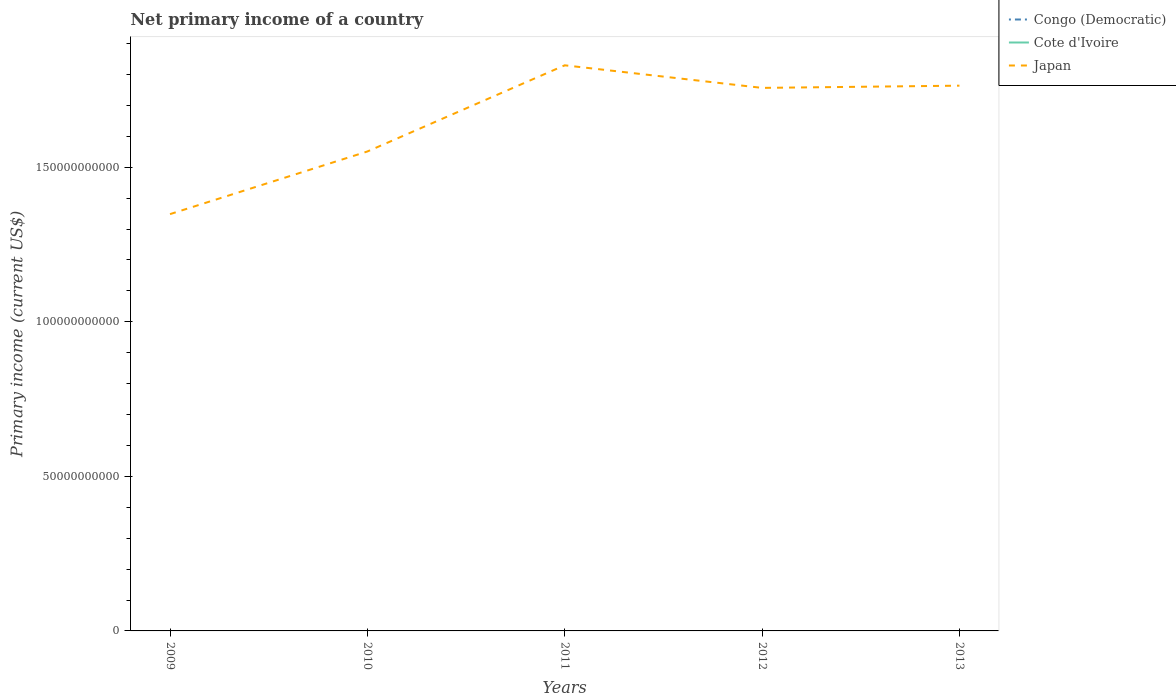Does the line corresponding to Japan intersect with the line corresponding to Congo (Democratic)?
Offer a terse response. No. Is the number of lines equal to the number of legend labels?
Ensure brevity in your answer.  No. Across all years, what is the maximum primary income in Congo (Democratic)?
Ensure brevity in your answer.  0. What is the total primary income in Japan in the graph?
Your response must be concise. 7.31e+09. Is the primary income in Cote d'Ivoire strictly greater than the primary income in Japan over the years?
Make the answer very short. Yes. How many lines are there?
Your answer should be very brief. 1. What is the difference between two consecutive major ticks on the Y-axis?
Provide a succinct answer. 5.00e+1. Are the values on the major ticks of Y-axis written in scientific E-notation?
Ensure brevity in your answer.  No. Does the graph contain any zero values?
Ensure brevity in your answer.  Yes. Does the graph contain grids?
Your answer should be very brief. No. What is the title of the graph?
Your response must be concise. Net primary income of a country. Does "Australia" appear as one of the legend labels in the graph?
Provide a succinct answer. No. What is the label or title of the X-axis?
Offer a very short reply. Years. What is the label or title of the Y-axis?
Offer a terse response. Primary income (current US$). What is the Primary income (current US$) of Cote d'Ivoire in 2009?
Your answer should be compact. 0. What is the Primary income (current US$) of Japan in 2009?
Keep it short and to the point. 1.35e+11. What is the Primary income (current US$) in Congo (Democratic) in 2010?
Provide a short and direct response. 0. What is the Primary income (current US$) of Japan in 2010?
Ensure brevity in your answer.  1.55e+11. What is the Primary income (current US$) of Cote d'Ivoire in 2011?
Provide a short and direct response. 0. What is the Primary income (current US$) of Japan in 2011?
Provide a short and direct response. 1.83e+11. What is the Primary income (current US$) in Congo (Democratic) in 2012?
Offer a terse response. 0. What is the Primary income (current US$) in Japan in 2012?
Offer a terse response. 1.76e+11. What is the Primary income (current US$) of Congo (Democratic) in 2013?
Provide a succinct answer. 0. What is the Primary income (current US$) in Cote d'Ivoire in 2013?
Keep it short and to the point. 0. What is the Primary income (current US$) in Japan in 2013?
Keep it short and to the point. 1.76e+11. Across all years, what is the maximum Primary income (current US$) in Japan?
Provide a succinct answer. 1.83e+11. Across all years, what is the minimum Primary income (current US$) of Japan?
Ensure brevity in your answer.  1.35e+11. What is the total Primary income (current US$) in Japan in the graph?
Your answer should be compact. 8.25e+11. What is the difference between the Primary income (current US$) in Japan in 2009 and that in 2010?
Your response must be concise. -2.03e+1. What is the difference between the Primary income (current US$) of Japan in 2009 and that in 2011?
Your response must be concise. -4.81e+1. What is the difference between the Primary income (current US$) in Japan in 2009 and that in 2012?
Your answer should be compact. -4.08e+1. What is the difference between the Primary income (current US$) of Japan in 2009 and that in 2013?
Make the answer very short. -4.16e+1. What is the difference between the Primary income (current US$) of Japan in 2010 and that in 2011?
Keep it short and to the point. -2.79e+1. What is the difference between the Primary income (current US$) of Japan in 2010 and that in 2012?
Your answer should be very brief. -2.06e+1. What is the difference between the Primary income (current US$) in Japan in 2010 and that in 2013?
Your response must be concise. -2.13e+1. What is the difference between the Primary income (current US$) of Japan in 2011 and that in 2012?
Your response must be concise. 7.31e+09. What is the difference between the Primary income (current US$) in Japan in 2011 and that in 2013?
Your answer should be very brief. 6.59e+09. What is the difference between the Primary income (current US$) of Japan in 2012 and that in 2013?
Ensure brevity in your answer.  -7.19e+08. What is the average Primary income (current US$) in Congo (Democratic) per year?
Offer a terse response. 0. What is the average Primary income (current US$) in Cote d'Ivoire per year?
Keep it short and to the point. 0. What is the average Primary income (current US$) of Japan per year?
Offer a very short reply. 1.65e+11. What is the ratio of the Primary income (current US$) in Japan in 2009 to that in 2010?
Your answer should be compact. 0.87. What is the ratio of the Primary income (current US$) of Japan in 2009 to that in 2011?
Offer a very short reply. 0.74. What is the ratio of the Primary income (current US$) of Japan in 2009 to that in 2012?
Your answer should be very brief. 0.77. What is the ratio of the Primary income (current US$) in Japan in 2009 to that in 2013?
Offer a terse response. 0.76. What is the ratio of the Primary income (current US$) of Japan in 2010 to that in 2011?
Ensure brevity in your answer.  0.85. What is the ratio of the Primary income (current US$) in Japan in 2010 to that in 2012?
Your response must be concise. 0.88. What is the ratio of the Primary income (current US$) in Japan in 2010 to that in 2013?
Make the answer very short. 0.88. What is the ratio of the Primary income (current US$) in Japan in 2011 to that in 2012?
Your response must be concise. 1.04. What is the ratio of the Primary income (current US$) of Japan in 2011 to that in 2013?
Give a very brief answer. 1.04. What is the difference between the highest and the second highest Primary income (current US$) of Japan?
Provide a short and direct response. 6.59e+09. What is the difference between the highest and the lowest Primary income (current US$) of Japan?
Your response must be concise. 4.81e+1. 